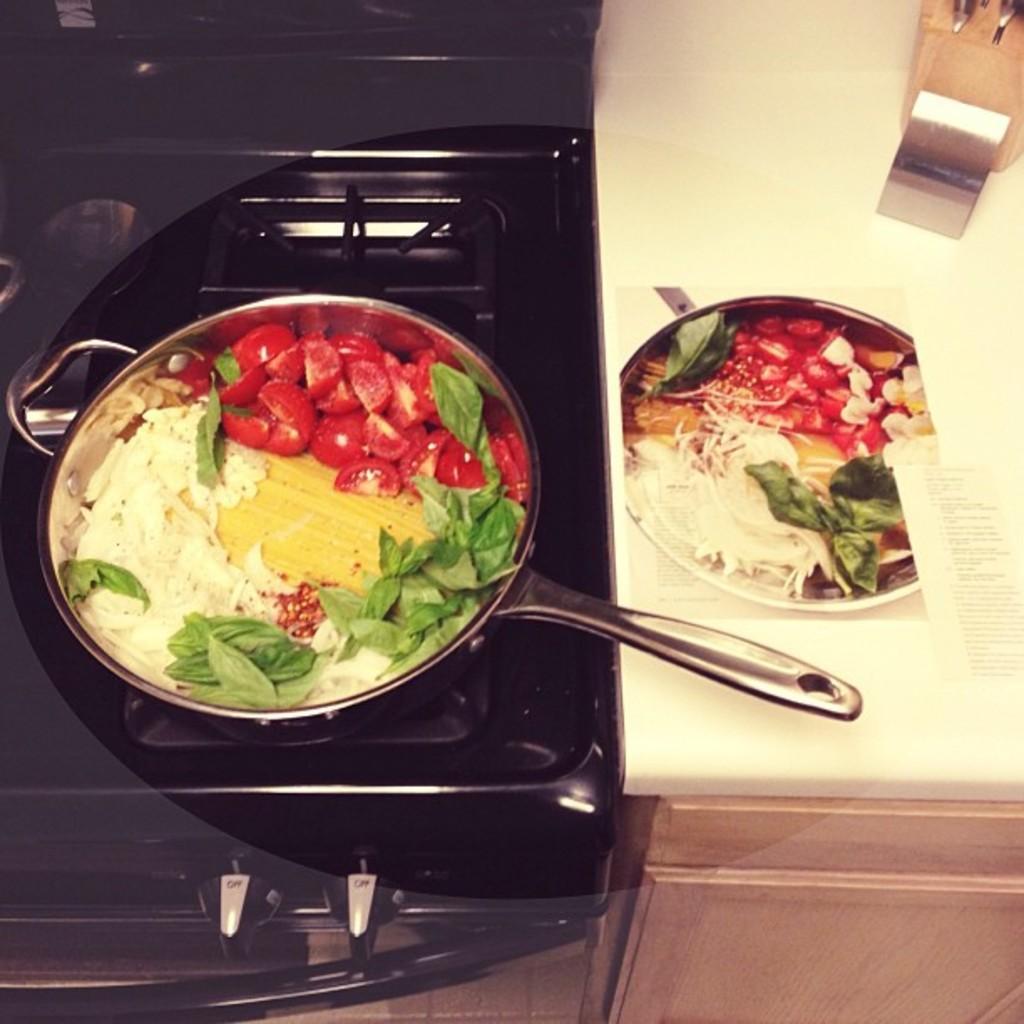Describe this image in one or two sentences. In this image I can see the stove , in the pan I can see a food item , on the right side I can see a table, on the table I can see a plate, plate consists of food item 